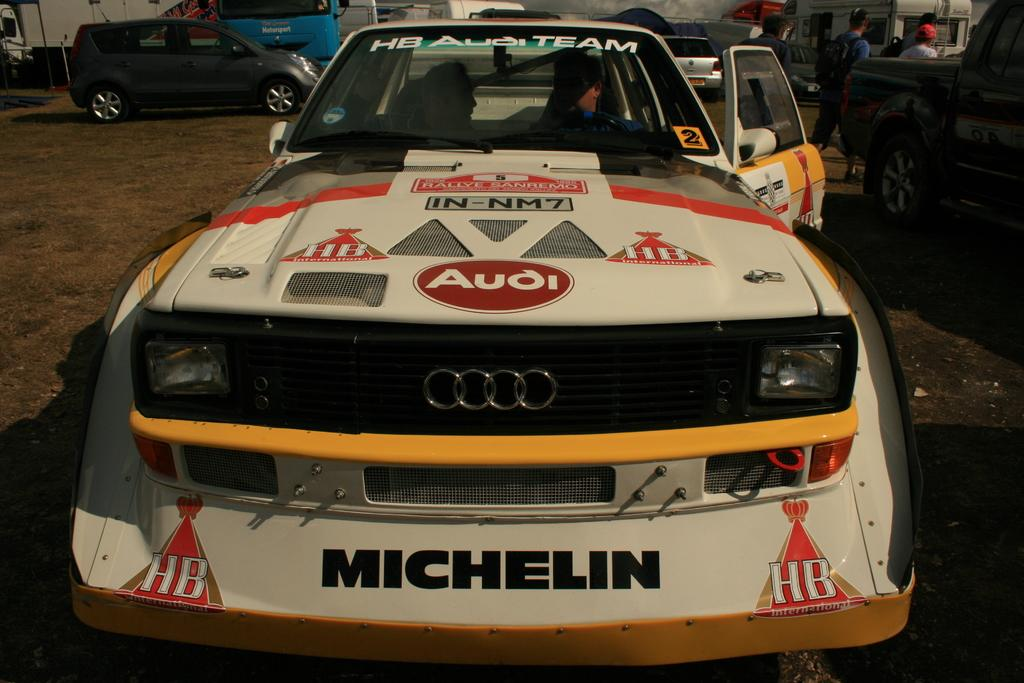Provide a one-sentence caption for the provided image. An Audi race car sits outside with the driver door ajar. 